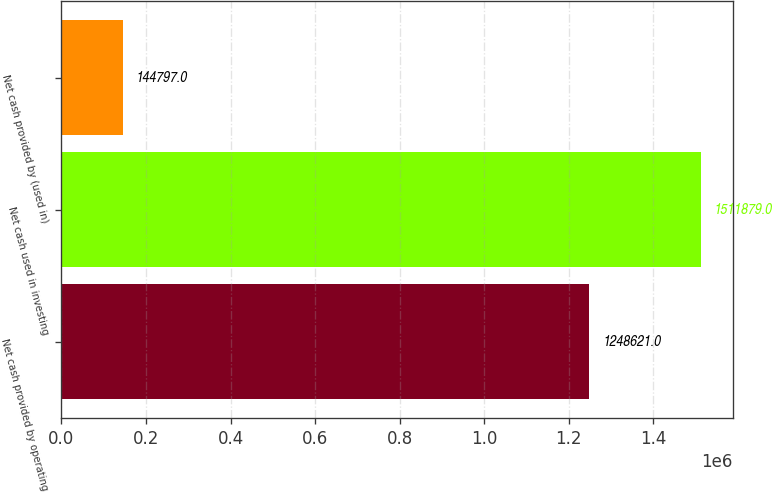<chart> <loc_0><loc_0><loc_500><loc_500><bar_chart><fcel>Net cash provided by operating<fcel>Net cash used in investing<fcel>Net cash provided by (used in)<nl><fcel>1.24862e+06<fcel>1.51188e+06<fcel>144797<nl></chart> 